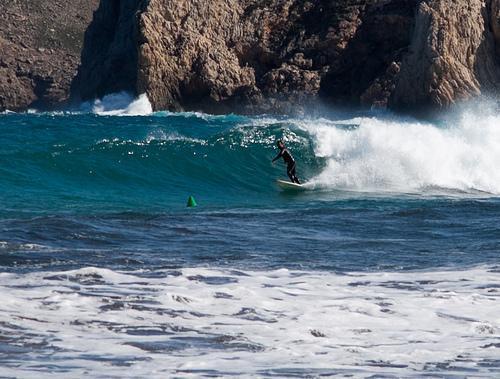How many people were surfing?
Give a very brief answer. 1. 